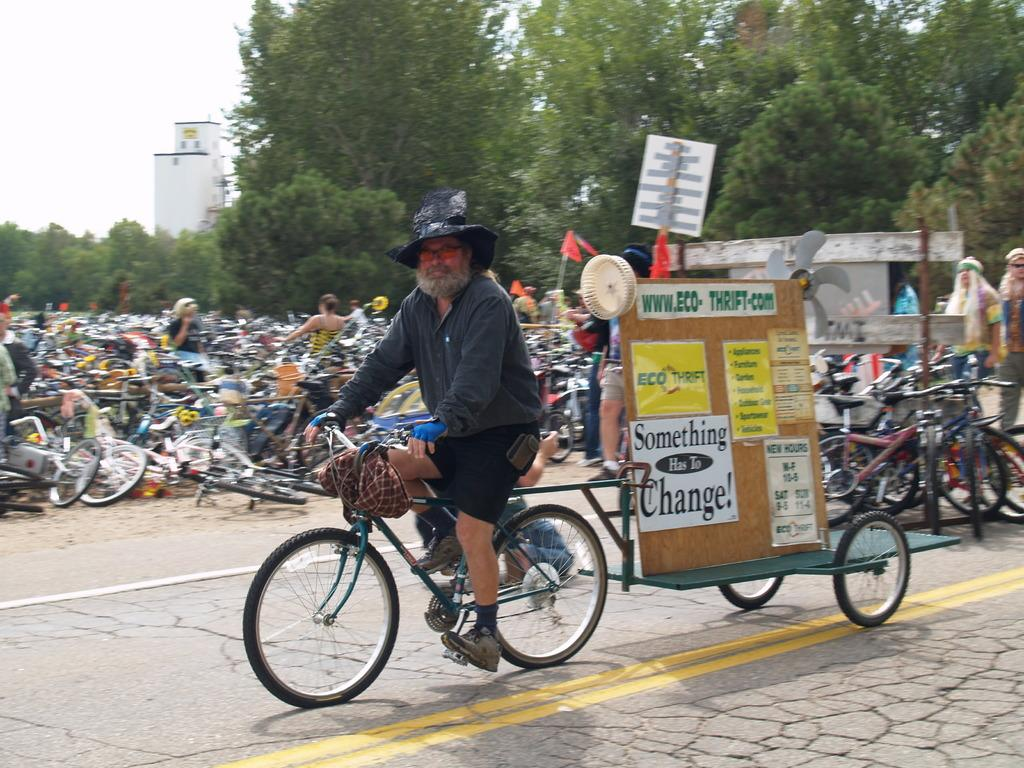What type of vehicles are in the image? There are bicycles in the image. Who or what is present in the image besides the bicycles? There are people, boards, flags, and a building in the image. What can be seen in the background of the image? The sky is visible in the background of the image. What type of terrain is visible in the image? There is a road and trees in the image, suggesting a combination of urban and natural environments. How many stockings are hanging from the bicycles in the image? There are no stockings present in the image; it features bicycles, people, boards, flags, a road, trees, a building, and the sky. 